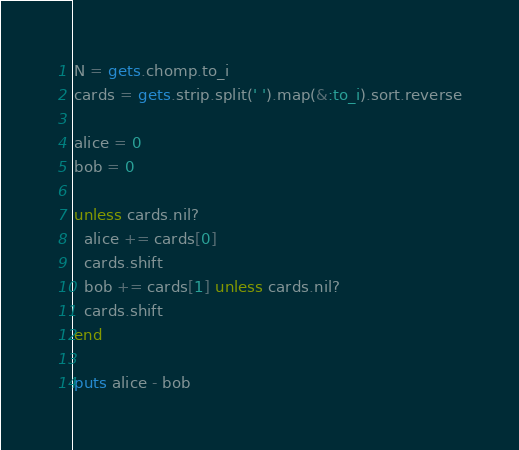<code> <loc_0><loc_0><loc_500><loc_500><_Ruby_>N = gets.chomp.to_i
cards = gets.strip.split(' ').map(&:to_i).sort.reverse

alice = 0
bob = 0

unless cards.nil?
  alice += cards[0]
  cards.shift
  bob += cards[1] unless cards.nil?
  cards.shift
end

puts alice - bob</code> 